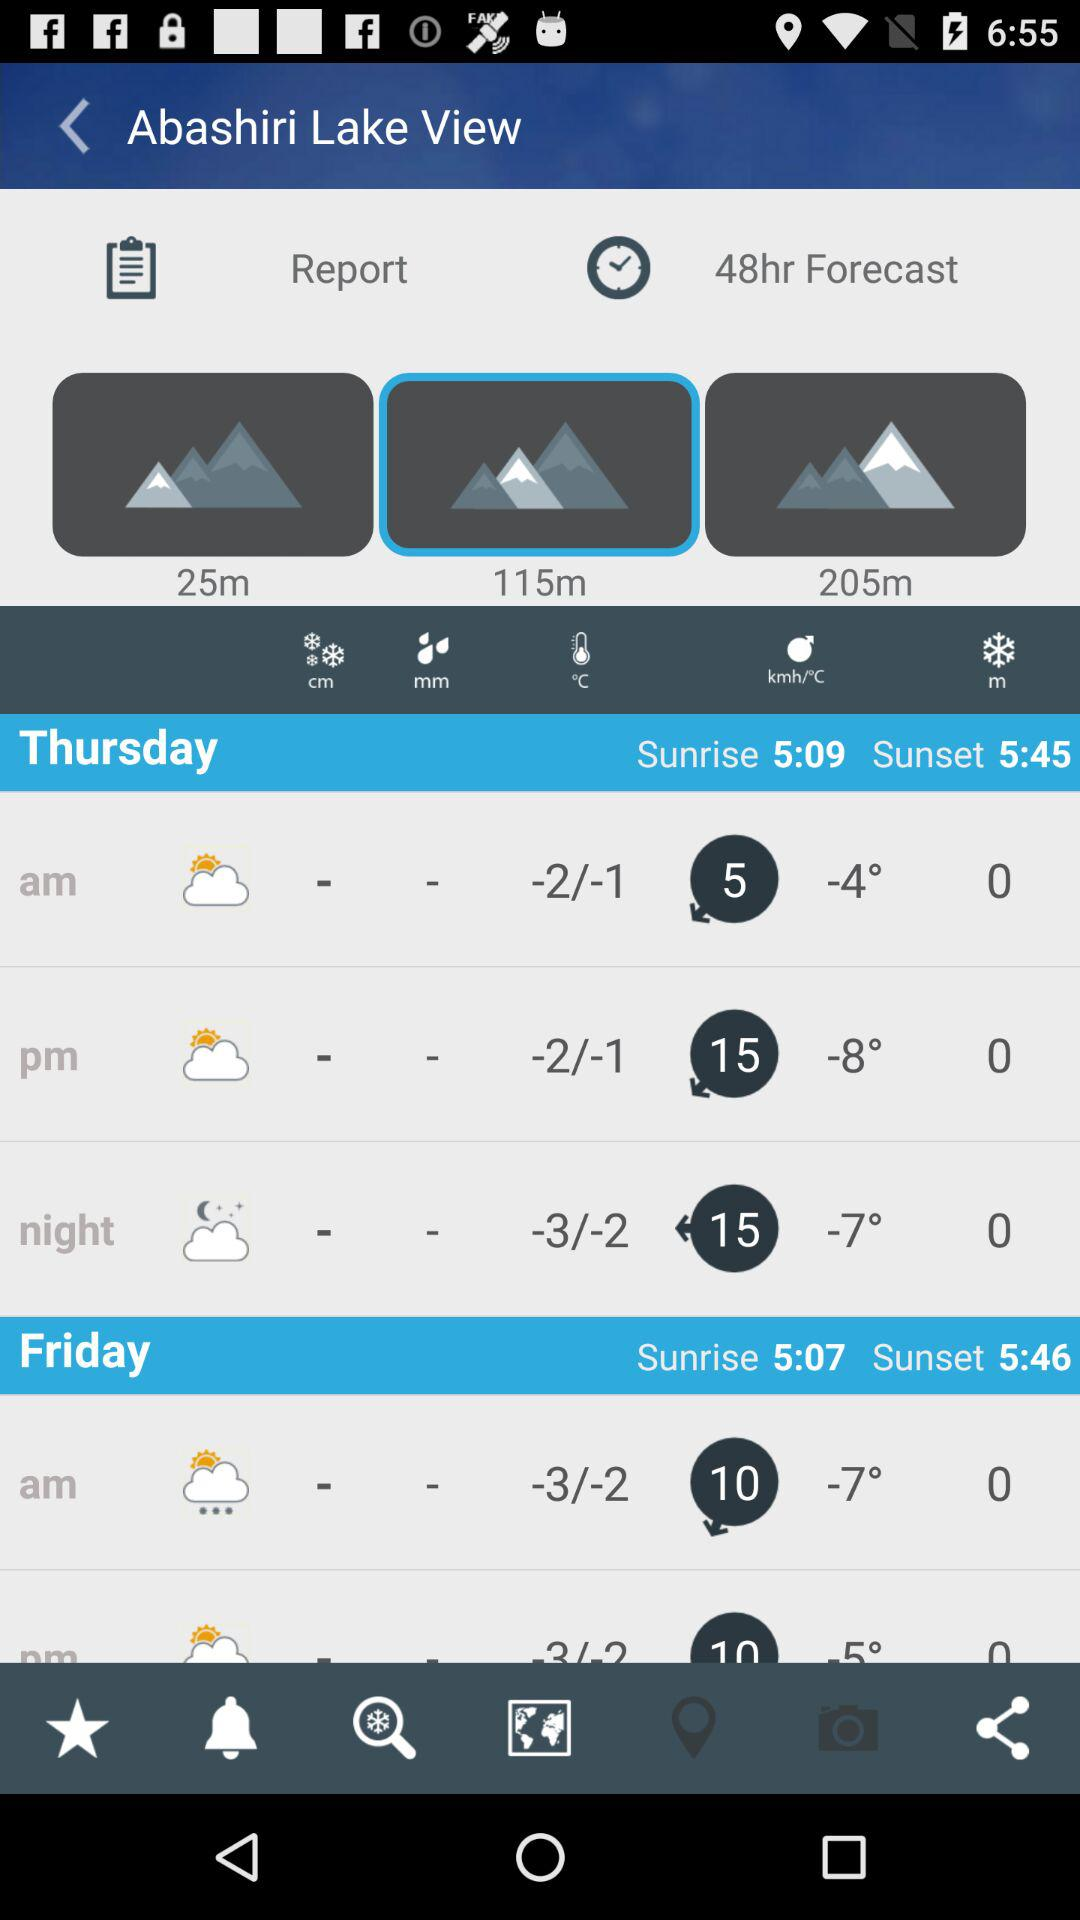What is the sunset time on Friday? The sunset time is 5:46. 